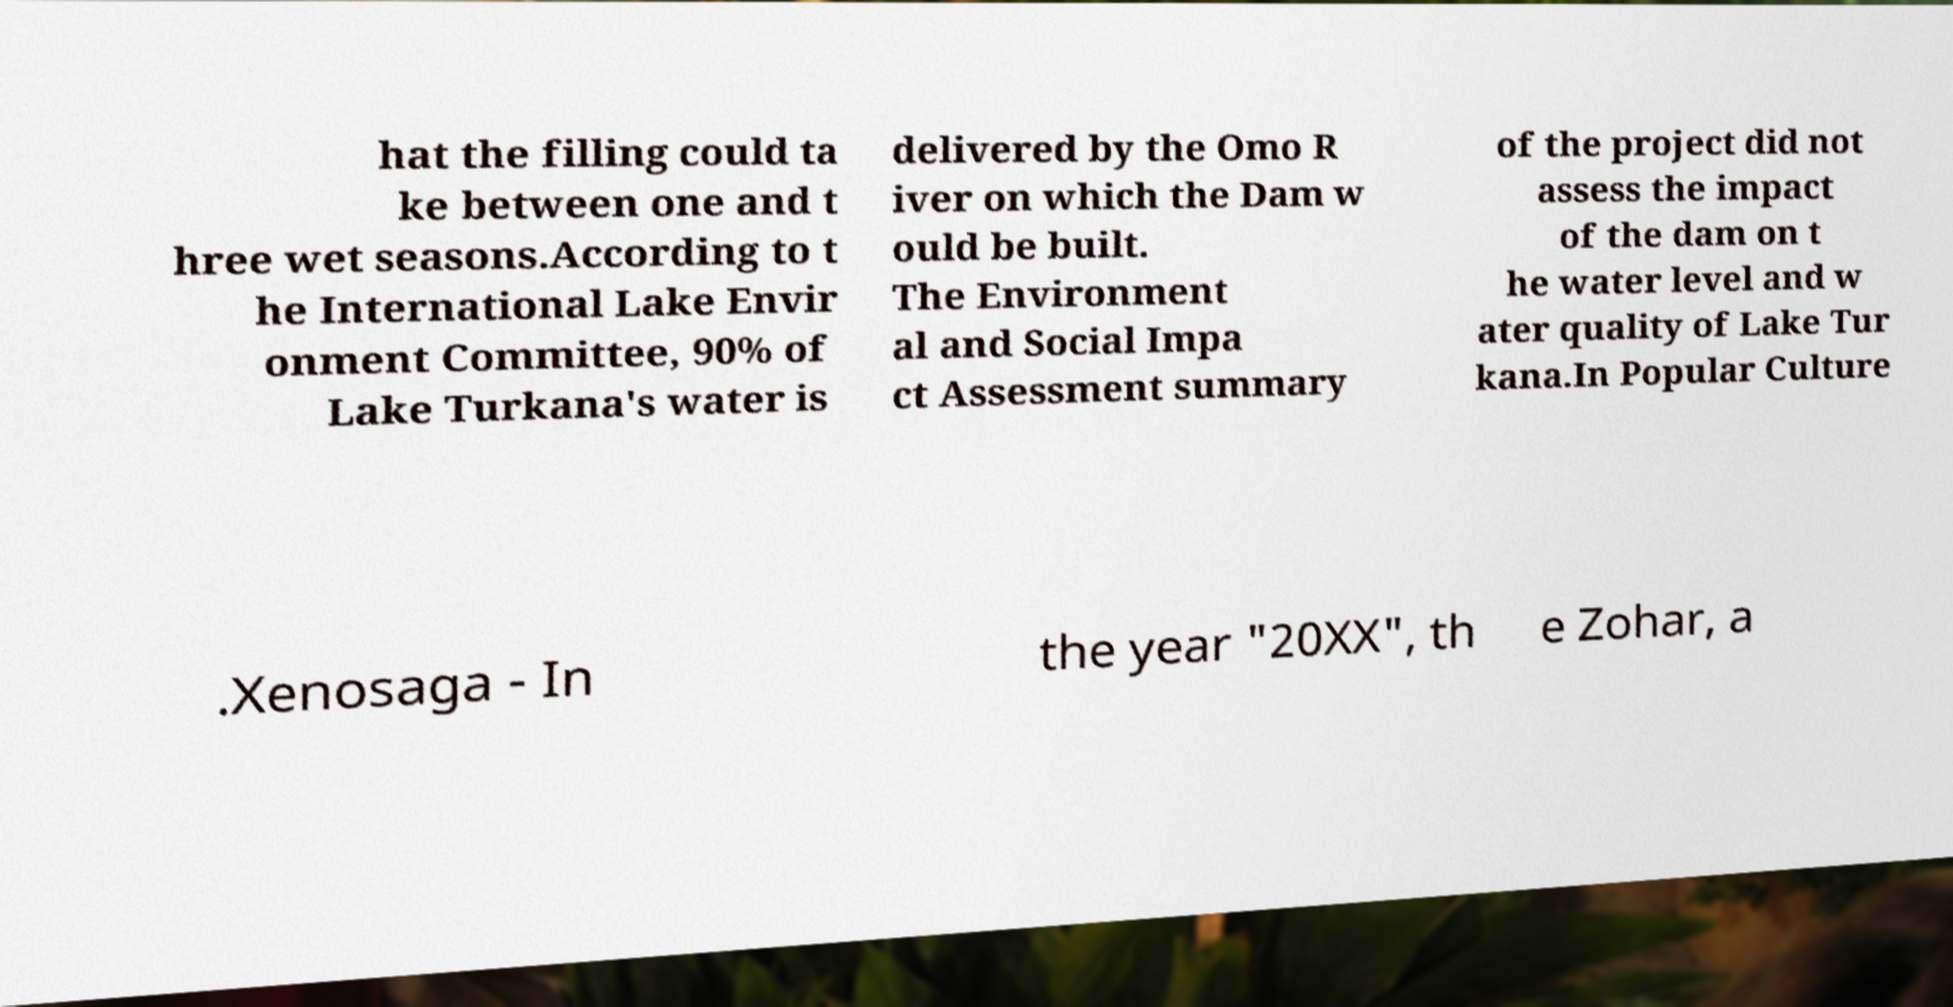Please identify and transcribe the text found in this image. hat the filling could ta ke between one and t hree wet seasons.According to t he International Lake Envir onment Committee, 90% of Lake Turkana's water is delivered by the Omo R iver on which the Dam w ould be built. The Environment al and Social Impa ct Assessment summary of the project did not assess the impact of the dam on t he water level and w ater quality of Lake Tur kana.In Popular Culture .Xenosaga - In the year "20XX", th e Zohar, a 